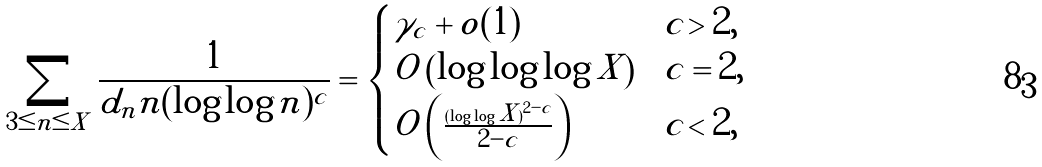<formula> <loc_0><loc_0><loc_500><loc_500>\sum _ { 3 \leq n \leq X } \frac { 1 } { d _ { n } n ( \log \log n ) ^ { c } } = \begin{cases} \gamma _ { c } + o ( 1 ) & c > 2 , \\ O \left ( \log \log \log X \right ) & c = 2 , \\ O \left ( \frac { ( \log \log X ) ^ { 2 - c } } { 2 - c } \right ) & c < 2 , \end{cases}</formula> 